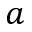<formula> <loc_0><loc_0><loc_500><loc_500>a</formula> 